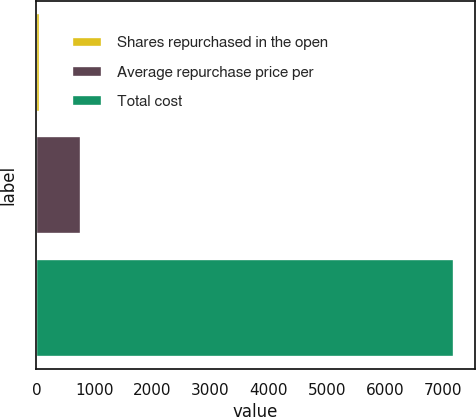Convert chart. <chart><loc_0><loc_0><loc_500><loc_500><bar_chart><fcel>Shares repurchased in the open<fcel>Average repurchase price per<fcel>Total cost<nl><fcel>58<fcel>771.4<fcel>7192<nl></chart> 